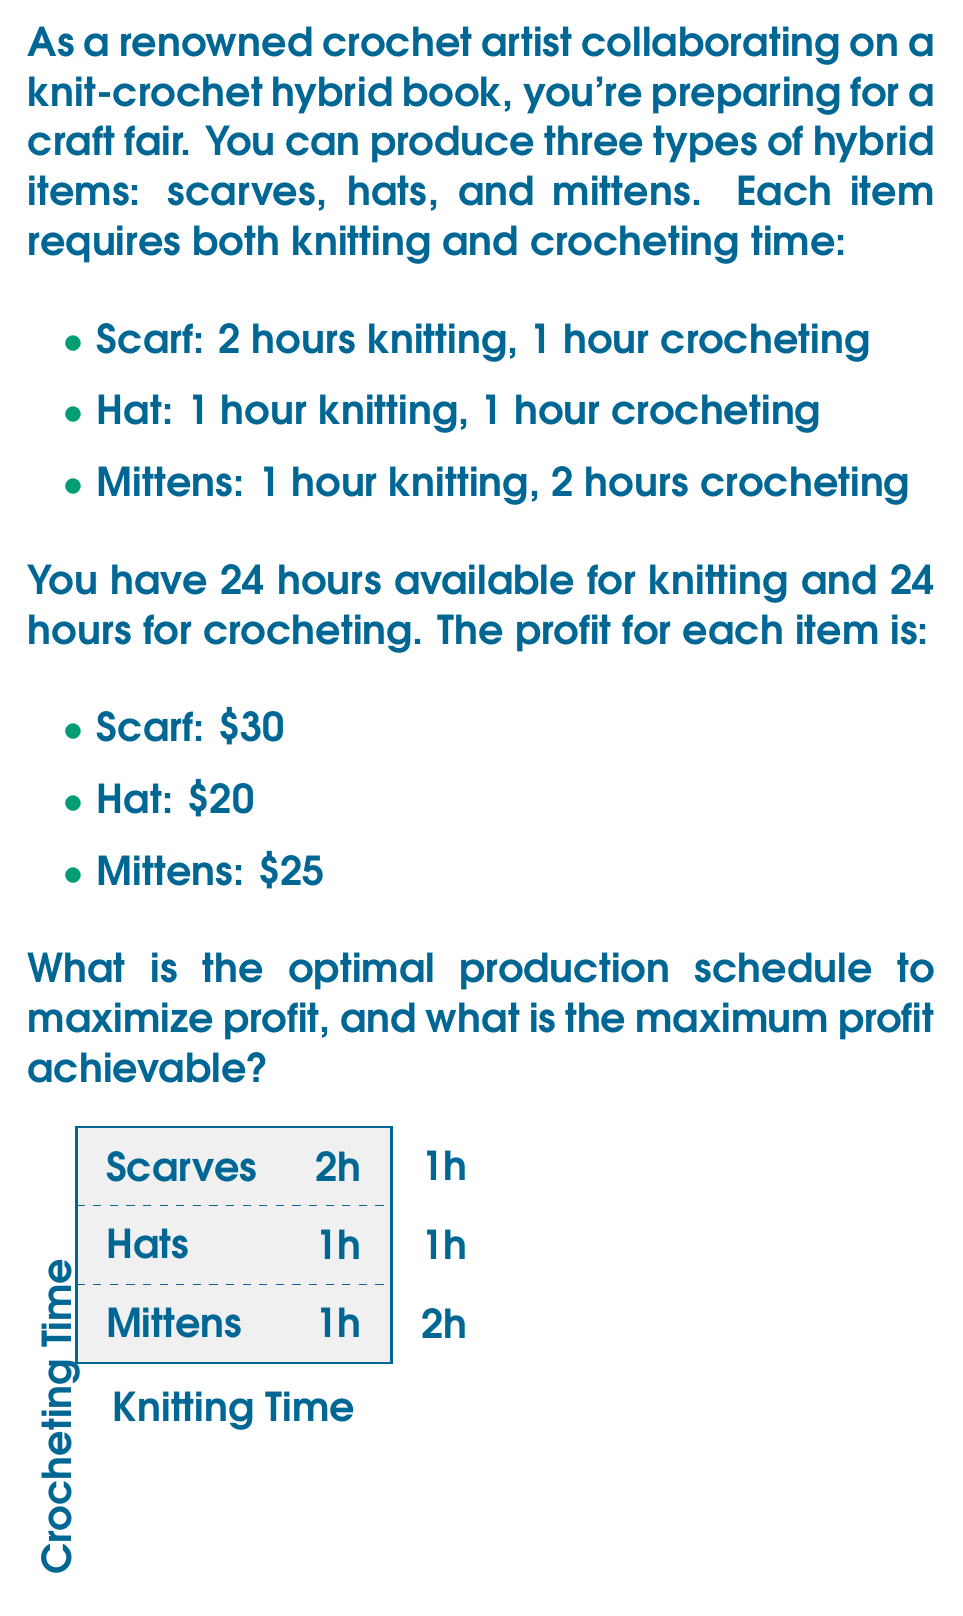Help me with this question. To solve this linear programming problem, we'll use the simplex method:

1) Define variables:
   Let $x$ = number of scarves
       $y$ = number of hats
       $z$ = number of mittens

2) Objective function (maximize profit):
   $\text{Maximize } P = 30x + 20y + 25z$

3) Constraints:
   Knitting time:   $2x + y + z \leq 24$
   Crocheting time: $x + y + 2z \leq 24$
   Non-negativity:  $x, y, z \geq 0$

4) Convert to standard form:
   $\text{Maximize } P = 30x + 20y + 25z$
   Subject to:
   $2x + y + z + s_1 = 24$
   $x + y + 2z + s_2 = 24$
   $x, y, z, s_1, s_2 \geq 0$

   Where $s_1$ and $s_2$ are slack variables.

5) Initial tableau:
   $$
   \begin{array}{c|ccccc|c}
   & x & y & z & s_1 & s_2 & \text{RHS} \\
   \hline
   P & -30 & -20 & -25 & 0 & 0 & 0 \\
   s_1 & 2 & 1 & 1 & 1 & 0 & 24 \\
   s_2 & 1 & 1 & 2 & 0 & 1 & 24 \\
   \end{array}
   $$

6) Perform pivot operations until all entries in the objective row are non-negative.

7) Final tableau:
   $$
   \begin{array}{c|ccccc|c}
   & x & y & z & s_1 & s_2 & \text{RHS} \\
   \hline
   P & 0 & 0 & 0 & 10 & 5 & 600 \\
   x & 1 & 0 & 0 & 1/2 & -1/2 & 8 \\
   y & 0 & 1 & 0 & -1/2 & 1/2 & 8 \\
   \end{array}
   $$

8) Optimal solution:
   $x = 8$ (scarves)
   $y = 8$ (hats)
   $z = 0$ (mittens)
   Maximum profit = $600
Answer: Produce 8 scarves and 8 hats for a maximum profit of $600. 